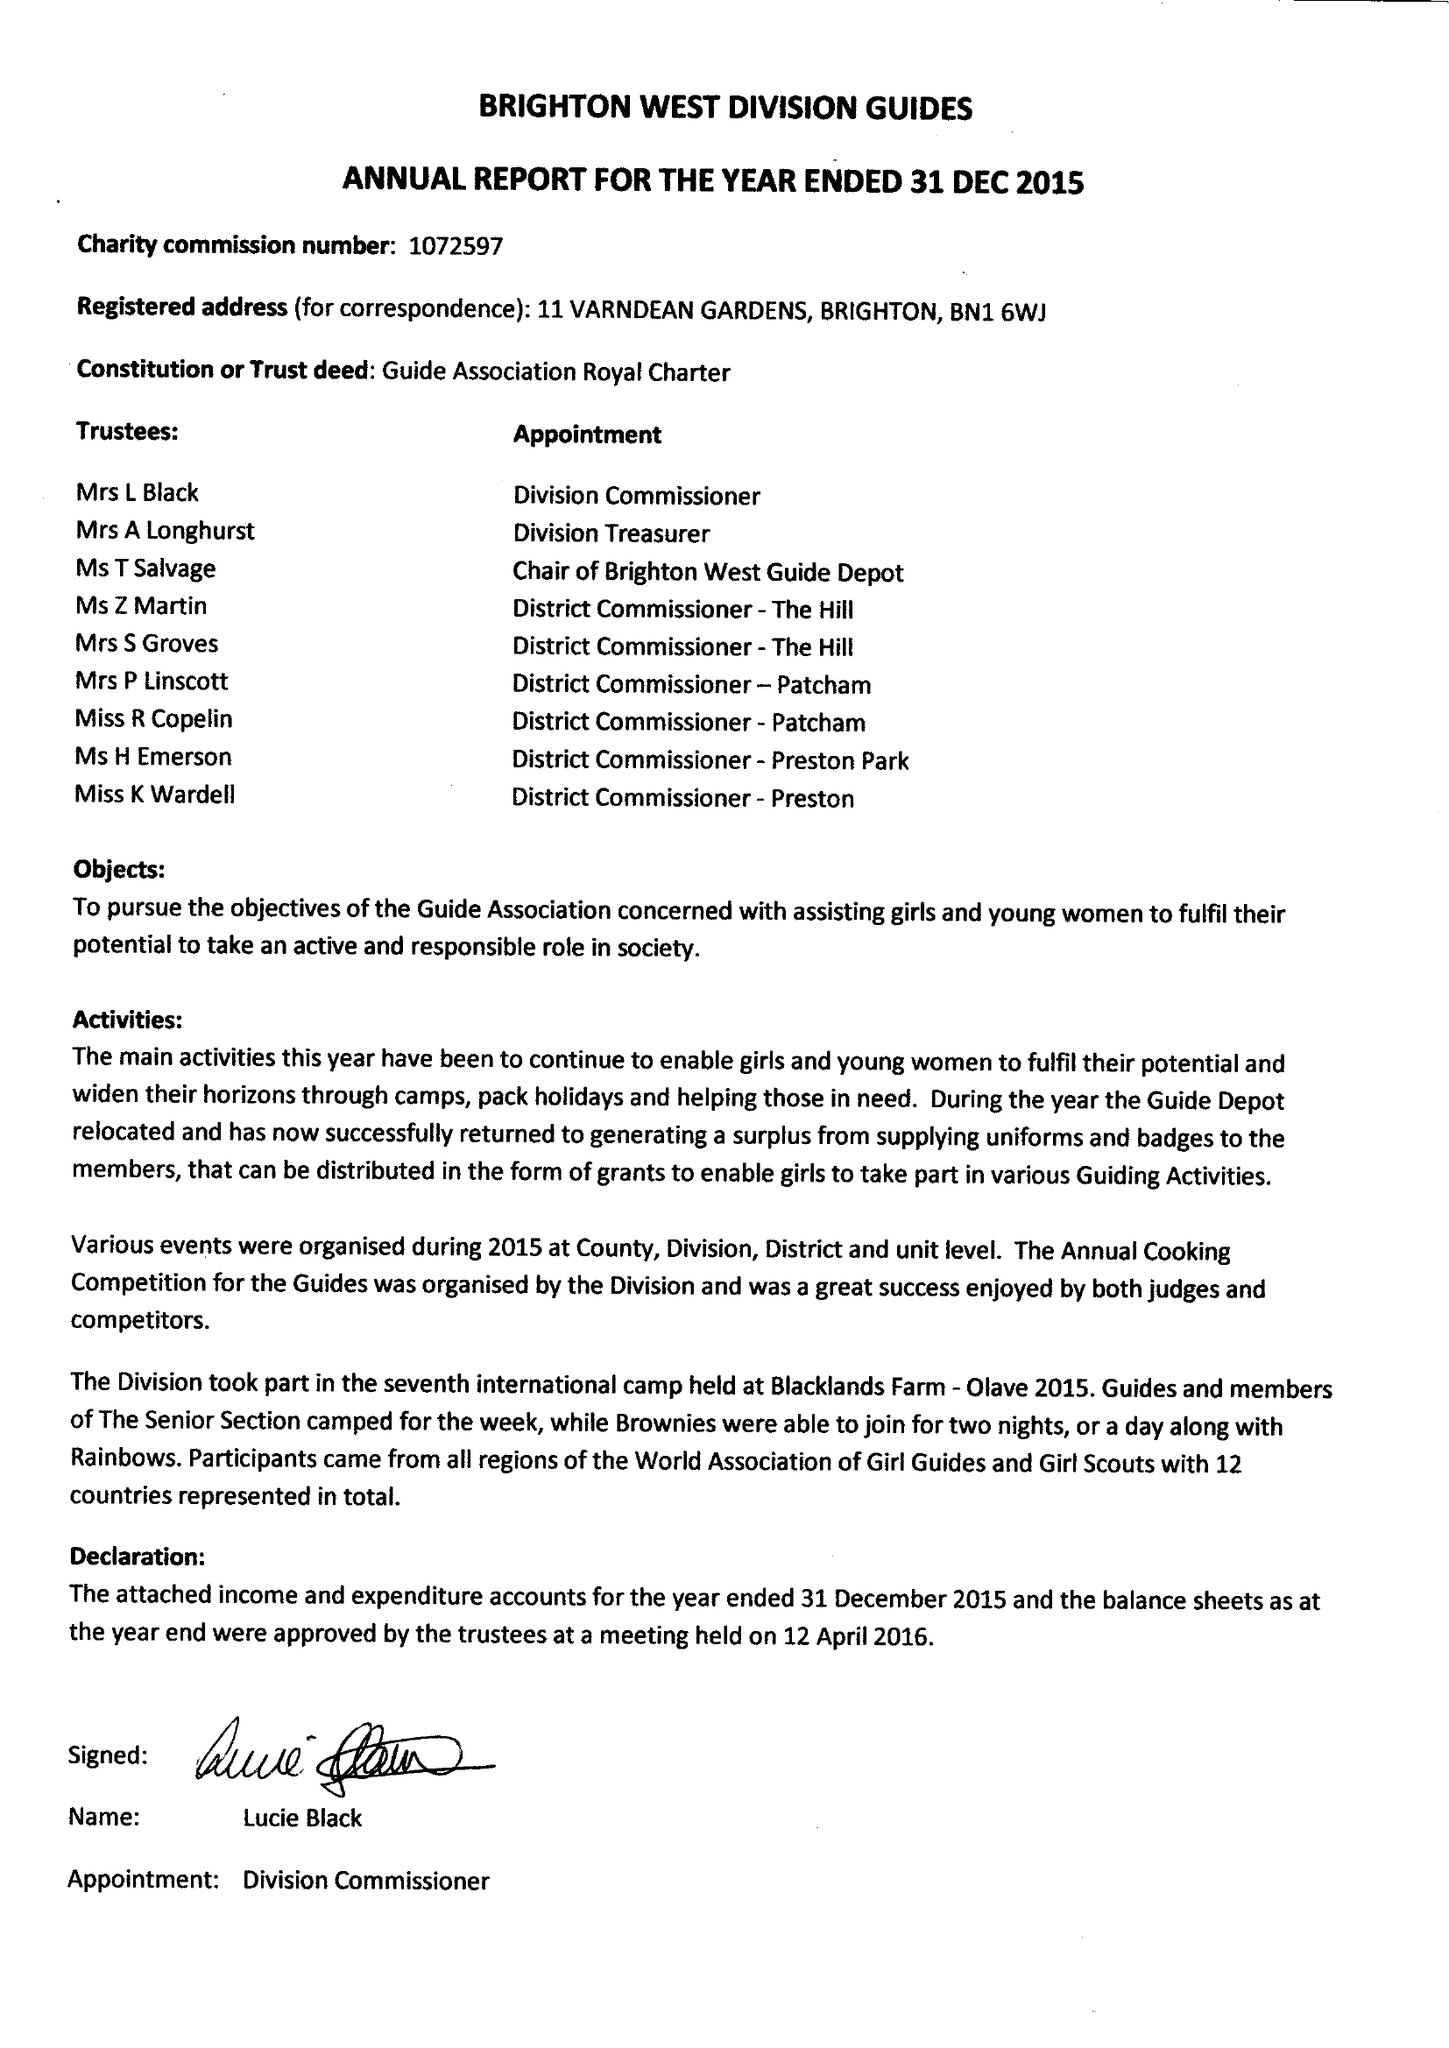What is the value for the charity_name?
Answer the question using a single word or phrase. Brighton West Division Guides 